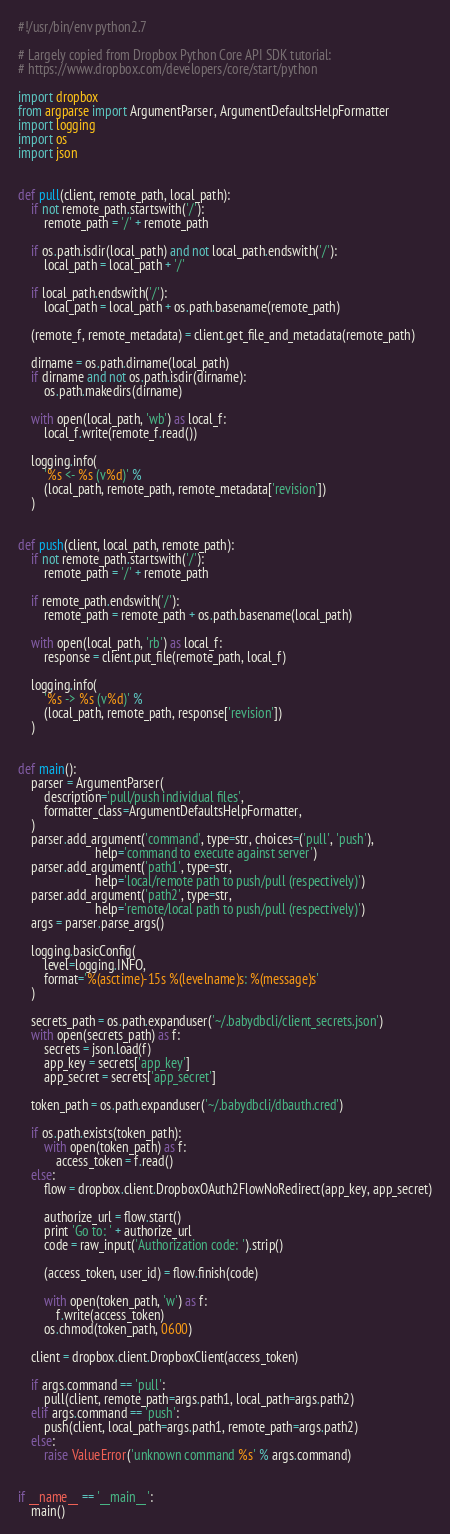Convert code to text. <code><loc_0><loc_0><loc_500><loc_500><_Python_>#!/usr/bin/env python2.7

# Largely copied from Dropbox Python Core API SDK tutorial:
# https://www.dropbox.com/developers/core/start/python

import dropbox
from argparse import ArgumentParser, ArgumentDefaultsHelpFormatter
import logging
import os
import json


def pull(client, remote_path, local_path):
    if not remote_path.startswith('/'):
        remote_path = '/' + remote_path

    if os.path.isdir(local_path) and not local_path.endswith('/'):
        local_path = local_path + '/'

    if local_path.endswith('/'):
        local_path = local_path + os.path.basename(remote_path)

    (remote_f, remote_metadata) = client.get_file_and_metadata(remote_path)

    dirname = os.path.dirname(local_path)
    if dirname and not os.path.isdir(dirname):
        os.path.makedirs(dirname)

    with open(local_path, 'wb') as local_f:
        local_f.write(remote_f.read())

    logging.info(
        '%s <- %s (v%d)' %
        (local_path, remote_path, remote_metadata['revision'])
    )


def push(client, local_path, remote_path):
    if not remote_path.startswith('/'):
        remote_path = '/' + remote_path

    if remote_path.endswith('/'):
        remote_path = remote_path + os.path.basename(local_path)

    with open(local_path, 'rb') as local_f:
        response = client.put_file(remote_path, local_f)

    logging.info(
        '%s -> %s (v%d)' %
        (local_path, remote_path, response['revision'])
    )


def main():
    parser = ArgumentParser(
        description='pull/push individual files',
        formatter_class=ArgumentDefaultsHelpFormatter,
    )
    parser.add_argument('command', type=str, choices=('pull', 'push'),
                        help='command to execute against server')
    parser.add_argument('path1', type=str,
                        help='local/remote path to push/pull (respectively)')
    parser.add_argument('path2', type=str,
                        help='remote/local path to push/pull (respectively)')
    args = parser.parse_args()

    logging.basicConfig(
        level=logging.INFO,
        format='%(asctime)-15s %(levelname)s: %(message)s'
    )

    secrets_path = os.path.expanduser('~/.babydbcli/client_secrets.json')
    with open(secrets_path) as f:
        secrets = json.load(f)
        app_key = secrets['app_key']
        app_secret = secrets['app_secret']

    token_path = os.path.expanduser('~/.babydbcli/dbauth.cred')

    if os.path.exists(token_path):
        with open(token_path) as f:
            access_token = f.read()
    else:
        flow = dropbox.client.DropboxOAuth2FlowNoRedirect(app_key, app_secret)

        authorize_url = flow.start()
        print 'Go to: ' + authorize_url
        code = raw_input('Authorization code: ').strip()

        (access_token, user_id) = flow.finish(code)

        with open(token_path, 'w') as f:
            f.write(access_token)
        os.chmod(token_path, 0600)

    client = dropbox.client.DropboxClient(access_token)

    if args.command == 'pull':
        pull(client, remote_path=args.path1, local_path=args.path2)
    elif args.command == 'push':
        push(client, local_path=args.path1, remote_path=args.path2)
    else:
        raise ValueError('unknown command %s' % args.command)


if __name__ == '__main__':
    main()
</code> 